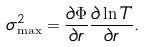Convert formula to latex. <formula><loc_0><loc_0><loc_500><loc_500>\sigma ^ { 2 } _ { \max } = \frac { \partial \Phi } { \partial r } \frac { \partial \ln T } { \partial r } .</formula> 